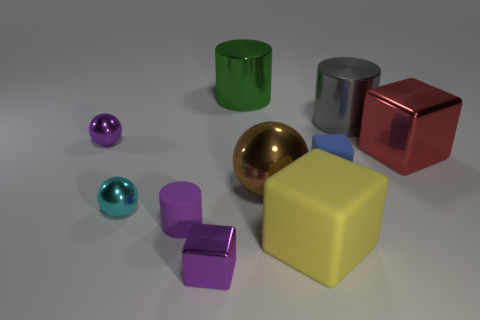Subtract all cylinders. How many objects are left? 7 Subtract 0 red cylinders. How many objects are left? 10 Subtract all big green cylinders. Subtract all cyan metal objects. How many objects are left? 8 Add 7 purple metallic objects. How many purple metallic objects are left? 9 Add 2 cyan metal spheres. How many cyan metal spheres exist? 3 